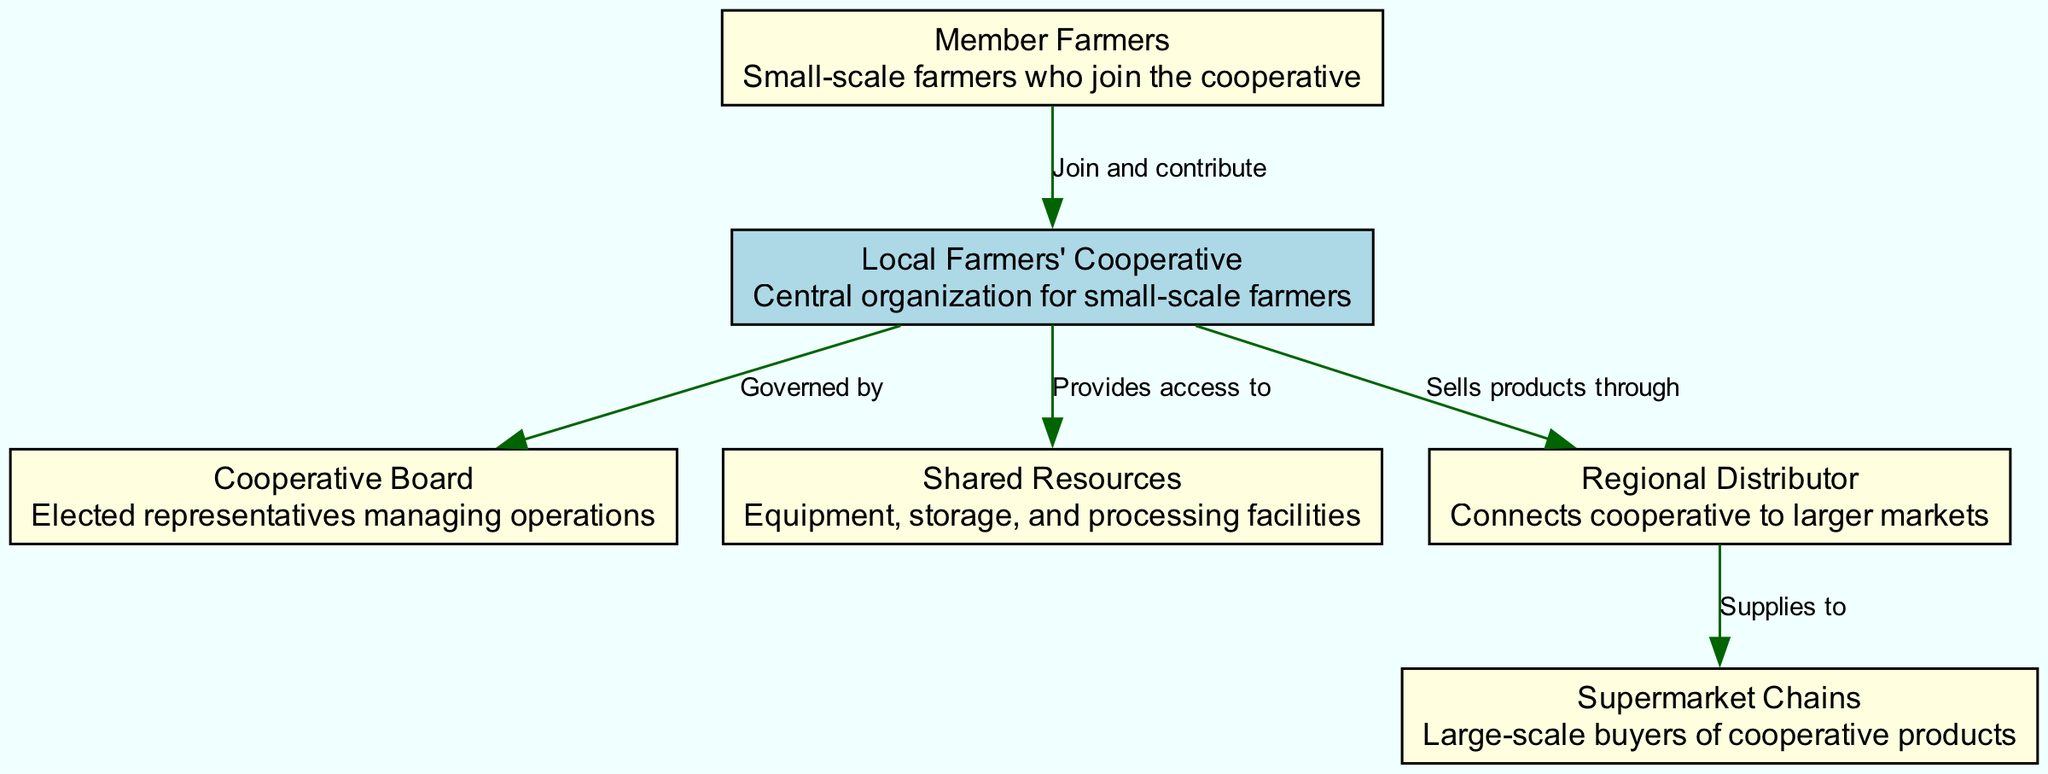What is the central organization in the diagram? The diagram shows that the "Local Farmers' Cooperative" is the central organization, as it is connected to all other nodes and represents the main focus of the cooperative structure.
Answer: Local Farmers' Cooperative How many member farmers are connected to the cooperative? According to the diagram, there is one edge indicating that "Member Farmers" join and contribute to the "Local Farmers' Cooperative," signifying a direct connection and involvement.
Answer: One What does the cooperative provide access to? The diagram states that the "Local Farmers' Cooperative" provides access to "Shared Resources," which includes equipment, storage, and processing facilities that member farmers can utilize.
Answer: Shared Resources Who governs the local farmers' cooperative? The edge labeled "Governed by" connects the "Cooperative Board" to the "Local Farmers' Cooperative," indicating that this board is responsible for overseeing the operations of the cooperative.
Answer: Cooperative Board How does the cooperative connect to larger markets? The "Local Farmers' Cooperative" has a direct edge to the "Regional Distributor," which is responsible for selling the products through to larger markets. This establishes the link between the cooperative and the wider market system.
Answer: Regional Distributor Which entity is a large-scale buyer of cooperative products? The diagram identifies "Supermarket Chains" as the large-scale buyers, showing a connection where the "Regional Distributor" supplies products to them, signifying a pathway for cooperative goods to reach larger consumers.
Answer: Supermarket Chains What is the role of the cooperative board? The "Cooperative Board" oversees the "Local Farmers' Cooperative," playing a crucial role in governance according to the diagram's description, which illustrates the management aspect of the cooperative system.
Answer: Management What types of resources are shared among member farmers? "Shared Resources" includes equipment, storage, and processing facilities, as mentioned in the diagram, indicating the various support structures available for member farmers.
Answer: Equipment, storage, and processing facilities How many edges are there in total in the diagram? By counting the connections listed in the diagram, there are five edges that represent various relationships between the nodes, illustrating the interactions and dependencies among them.
Answer: Five 